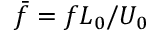Convert formula to latex. <formula><loc_0><loc_0><loc_500><loc_500>\bar { f } = f L _ { 0 } / U _ { 0 }</formula> 